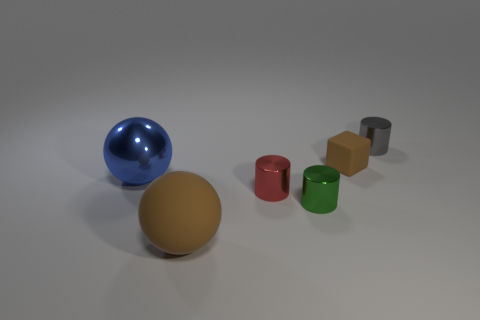How many other things are the same color as the big matte thing? Within the image, there appears to be one smaller object that shares the same grey color as the large matte sphere. 